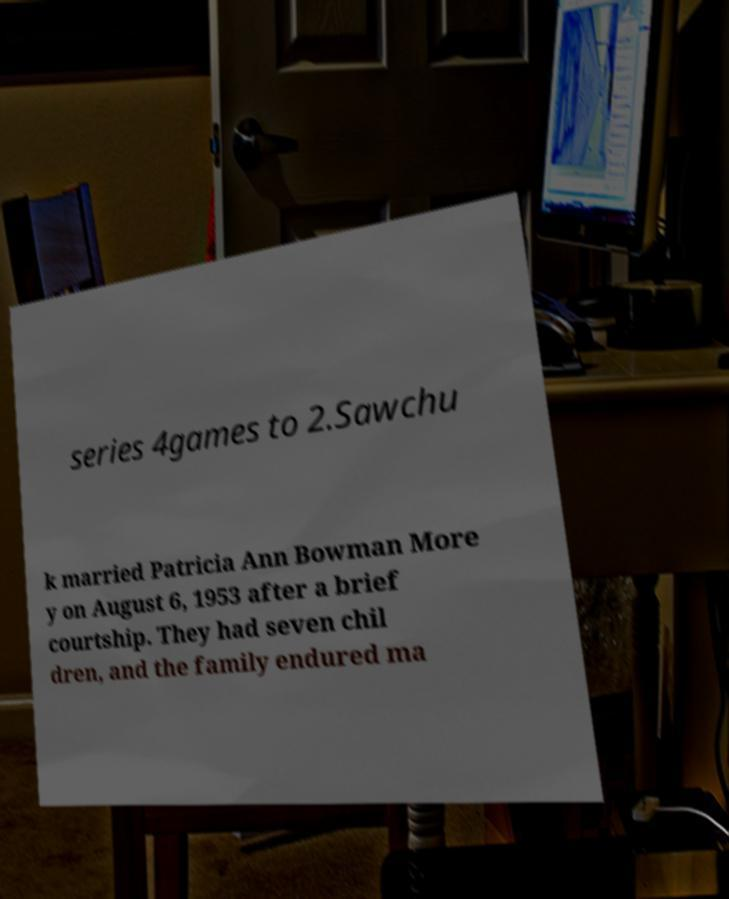Please identify and transcribe the text found in this image. series 4games to 2.Sawchu k married Patricia Ann Bowman More y on August 6, 1953 after a brief courtship. They had seven chil dren, and the family endured ma 